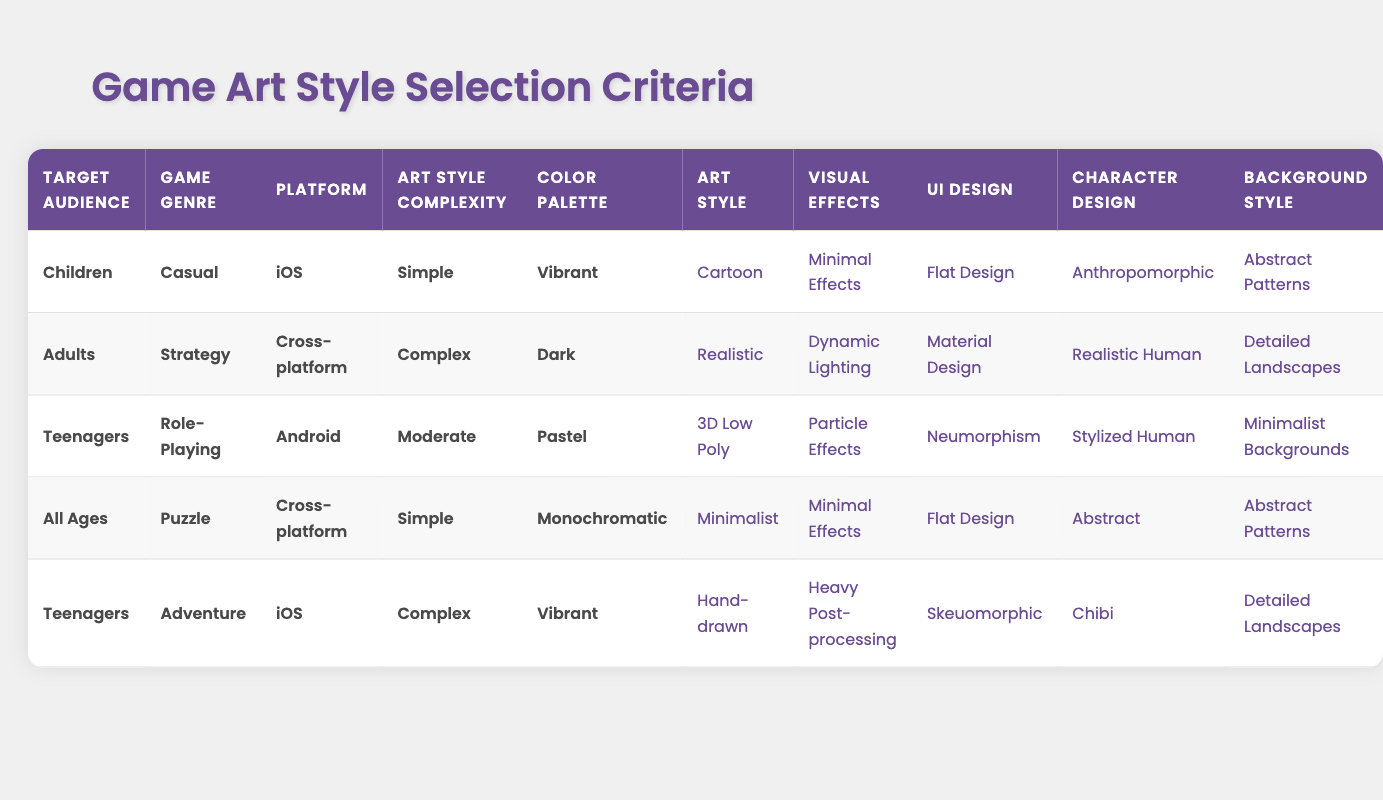What is the art style recommended for games targeting children in the casual genre on iOS? The specific row for "Children" in the "Casual" genre on "iOS" indicates that the recommended art style is "Cartoon."
Answer: Cartoon Which visual effects are suggested for adults playing a complex strategy game? For adults in a complex strategy game, the table shows that "Dynamic Lighting" is the recommended visual effect.
Answer: Dynamic Lighting Is minimal effects suitable for a puzzle game aimed at all ages? The data for "All Ages" in the "Puzzle" genre shows that "Minimal Effects" is indeed recommended.
Answer: Yes What background style is associated with vibrant color palettes in teenage adventure games? Looking at the relevant row for "Teenagers" in the "Adventure" genre with a "Vibrant" color palette, the background style is "Detailed Landscapes."
Answer: Detailed Landscapes What is the relationship between art style complexity and the recommended character design for teenagers in role-playing games? The complexity for teenagers in role-playing games is moderate, and the recommended character design is "Stylized Human." Therefore, there is a direct relationship where moderate complexity leads to stylized character designs.
Answer: Stylized Human How many action types are associated with the recommended styles for a casual game targeting children? For a casual game targeting children, there are 5 action types listed: Art Style, Visual Effects, UI Design, Character Design, and Background Style. Hence, this amounts to 5 action types.
Answer: 5 Does the table indicate any game that uses a realistic art style for cross-platform play? By examining the rows, I see that the only reference for a realistic art style relates to adults in a strategy game that is cross-platform. Thus, the answer is yes, it does indicate that.
Answer: Yes What is the character design suggested for a complex game aimed at teenagers? The table specifies that for teenagers in a complex game, the suggested character design is "Chibi."
Answer: Chibi What are the potential color palettes for a casual game targeting children? The row for children in the casual genre indicates that the potential color palette is "Vibrant." Since there's no other palette listed for this combination, it’s singular.
Answer: Vibrant 